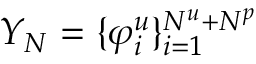<formula> <loc_0><loc_0><loc_500><loc_500>Y _ { N } = \{ \varphi _ { i } ^ { u } \} _ { i = 1 } ^ { N ^ { u } + N ^ { p } }</formula> 